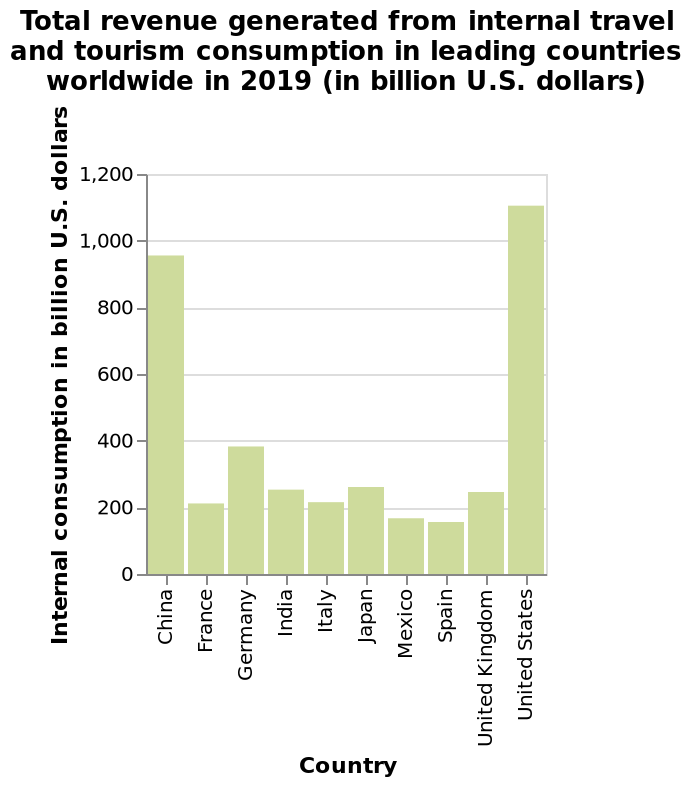<image>
What is the title of the bar plot?  The title of the bar plot is "Total revenue generated from internal travel and tourism consumption in leading countries worldwide in 2019 (in billion U.S. dollars)." Which two countries have almost double the total revenue generated from internal travel and tourism consumption compared to other countries? China and the United States. What is the range of the y-axis on the bar plot? The range of the y-axis on the bar plot is from 0 to 1,200 billion U.S. dollars. What is plotted on the x-axis of the bar plot?  The x-axis of the bar plot represents the countries. 